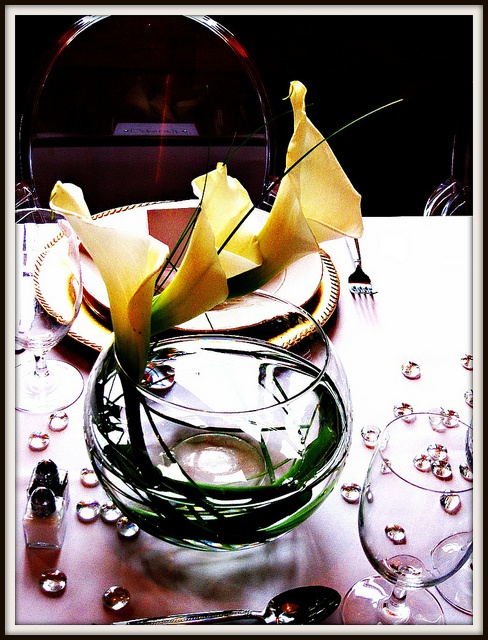Describe the objects in this image and their specific colors. I can see potted plant in black, white, and khaki tones, chair in black, purple, maroon, and white tones, vase in black, white, darkgray, and gray tones, wine glass in black, lavender, pink, darkgray, and violet tones, and wine glass in black, white, darkgray, and pink tones in this image. 